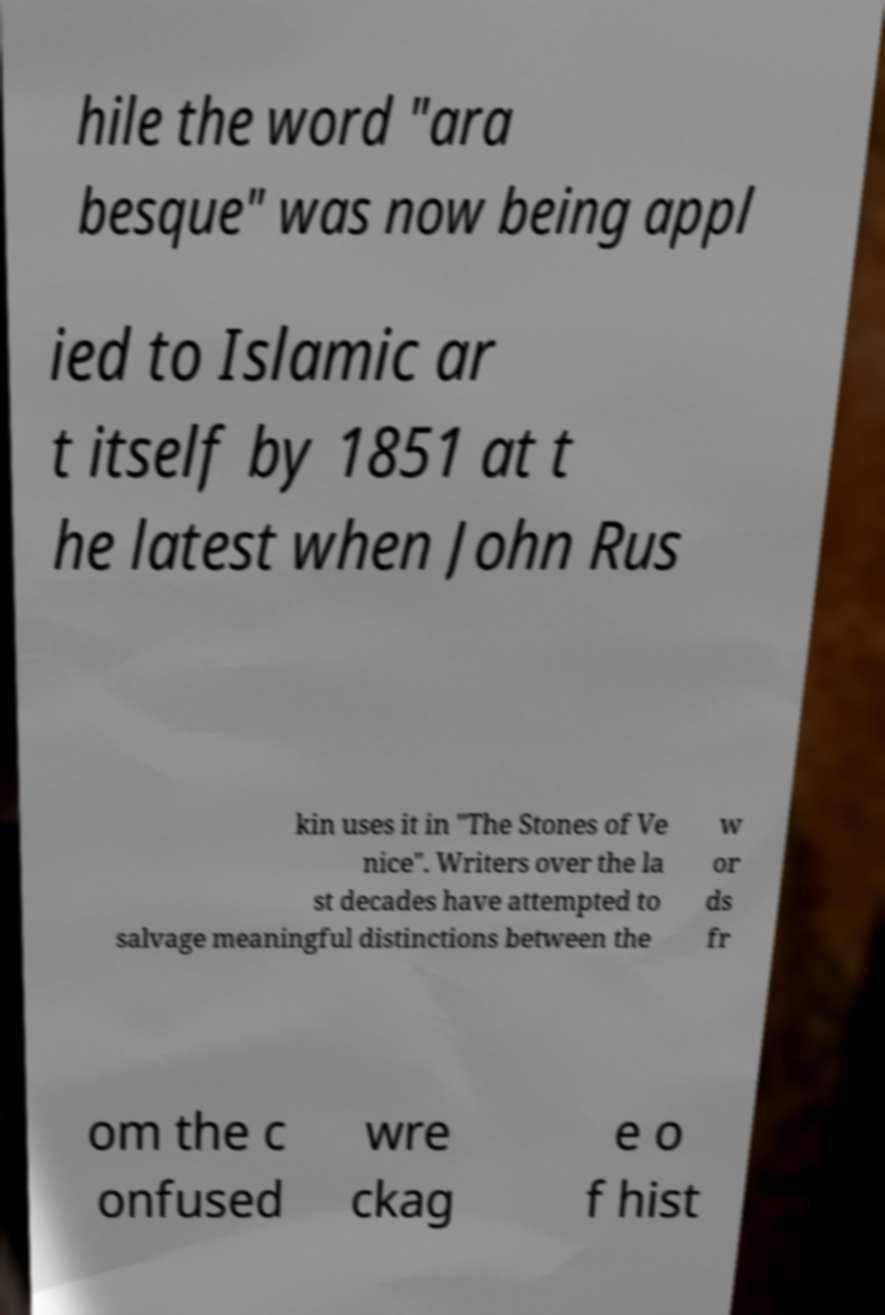I need the written content from this picture converted into text. Can you do that? hile the word "ara besque" was now being appl ied to Islamic ar t itself by 1851 at t he latest when John Rus kin uses it in "The Stones of Ve nice". Writers over the la st decades have attempted to salvage meaningful distinctions between the w or ds fr om the c onfused wre ckag e o f hist 